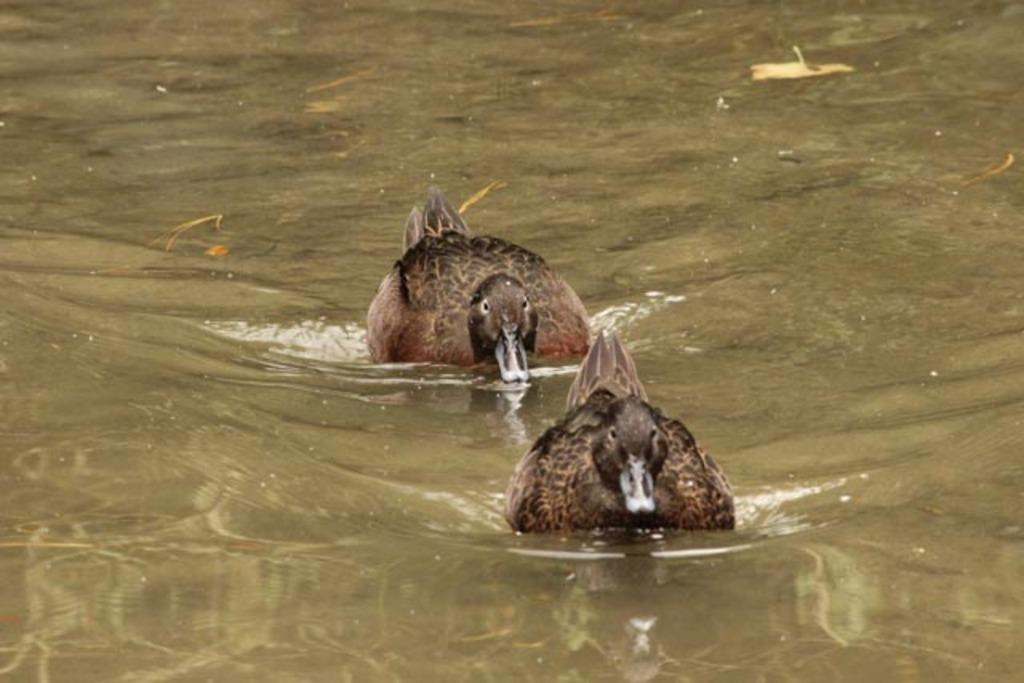What type of animals can be seen in the image? There are ducks in the image. Where are the ducks located? The ducks are on the water. What type of tank is visible in the image? There is no tank present in the image; it features ducks on the water. How can we help the ducks in the image? There is no need to help the ducks in the image, as they appear to be in their natural environment and are not in distress. 